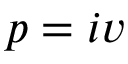<formula> <loc_0><loc_0><loc_500><loc_500>p = i v</formula> 